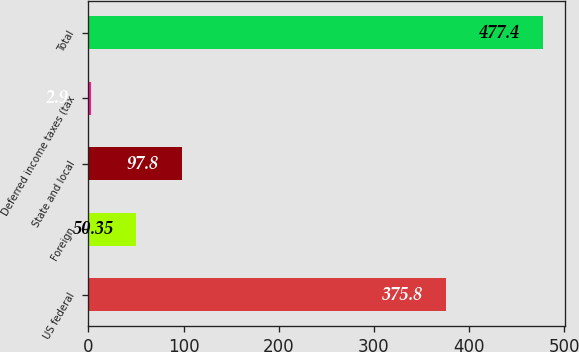<chart> <loc_0><loc_0><loc_500><loc_500><bar_chart><fcel>US federal<fcel>Foreign<fcel>State and local<fcel>Deferred income taxes (tax<fcel>Total<nl><fcel>375.8<fcel>50.35<fcel>97.8<fcel>2.9<fcel>477.4<nl></chart> 